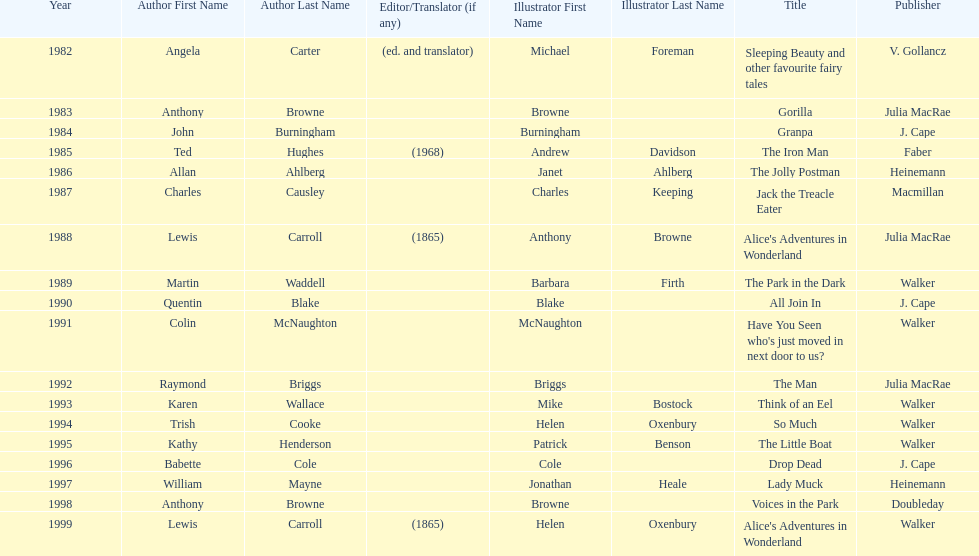What are the number of kurt maschler awards helen oxenbury has won? 2. 